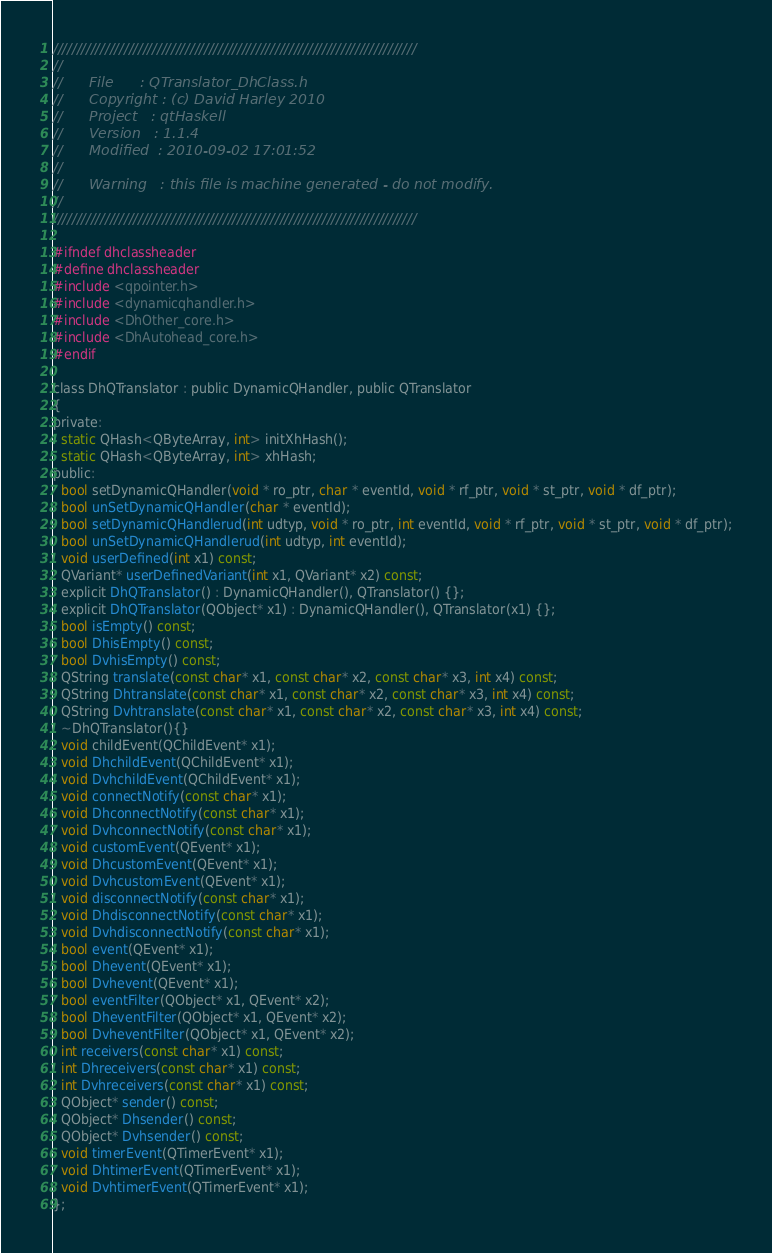<code> <loc_0><loc_0><loc_500><loc_500><_C_>/////////////////////////////////////////////////////////////////////////////
//      
//      File      : QTranslator_DhClass.h
//      Copyright : (c) David Harley 2010
//      Project   : qtHaskell
//      Version   : 1.1.4
//      Modified  : 2010-09-02 17:01:52
//      
//      Warning   : this file is machine generated - do not modify.
//      
/////////////////////////////////////////////////////////////////////////////

#ifndef dhclassheader
#define dhclassheader
#include <qpointer.h>
#include <dynamicqhandler.h>
#include <DhOther_core.h>
#include <DhAutohead_core.h>
#endif

class DhQTranslator : public DynamicQHandler, public QTranslator
{
private: 
  static QHash<QByteArray, int> initXhHash();
  static QHash<QByteArray, int> xhHash;
public:
  bool setDynamicQHandler(void * ro_ptr, char * eventId, void * rf_ptr, void * st_ptr, void * df_ptr);
  bool unSetDynamicQHandler(char * eventId);
  bool setDynamicQHandlerud(int udtyp, void * ro_ptr, int eventId, void * rf_ptr, void * st_ptr, void * df_ptr);
  bool unSetDynamicQHandlerud(int udtyp, int eventId);
  void userDefined(int x1) const;
  QVariant* userDefinedVariant(int x1, QVariant* x2) const;
  explicit DhQTranslator() : DynamicQHandler(), QTranslator() {};
  explicit DhQTranslator(QObject* x1) : DynamicQHandler(), QTranslator(x1) {};
  bool isEmpty() const;
  bool DhisEmpty() const;
  bool DvhisEmpty() const;
  QString translate(const char* x1, const char* x2, const char* x3, int x4) const;
  QString Dhtranslate(const char* x1, const char* x2, const char* x3, int x4) const;
  QString Dvhtranslate(const char* x1, const char* x2, const char* x3, int x4) const;
  ~DhQTranslator(){}
  void childEvent(QChildEvent* x1);
  void DhchildEvent(QChildEvent* x1);
  void DvhchildEvent(QChildEvent* x1);
  void connectNotify(const char* x1);
  void DhconnectNotify(const char* x1);
  void DvhconnectNotify(const char* x1);
  void customEvent(QEvent* x1);
  void DhcustomEvent(QEvent* x1);
  void DvhcustomEvent(QEvent* x1);
  void disconnectNotify(const char* x1);
  void DhdisconnectNotify(const char* x1);
  void DvhdisconnectNotify(const char* x1);
  bool event(QEvent* x1);
  bool Dhevent(QEvent* x1);
  bool Dvhevent(QEvent* x1);
  bool eventFilter(QObject* x1, QEvent* x2);
  bool DheventFilter(QObject* x1, QEvent* x2);
  bool DvheventFilter(QObject* x1, QEvent* x2);
  int receivers(const char* x1) const;
  int Dhreceivers(const char* x1) const;
  int Dvhreceivers(const char* x1) const;
  QObject* sender() const;
  QObject* Dhsender() const;
  QObject* Dvhsender() const;
  void timerEvent(QTimerEvent* x1);
  void DhtimerEvent(QTimerEvent* x1);
  void DvhtimerEvent(QTimerEvent* x1);
};

</code> 